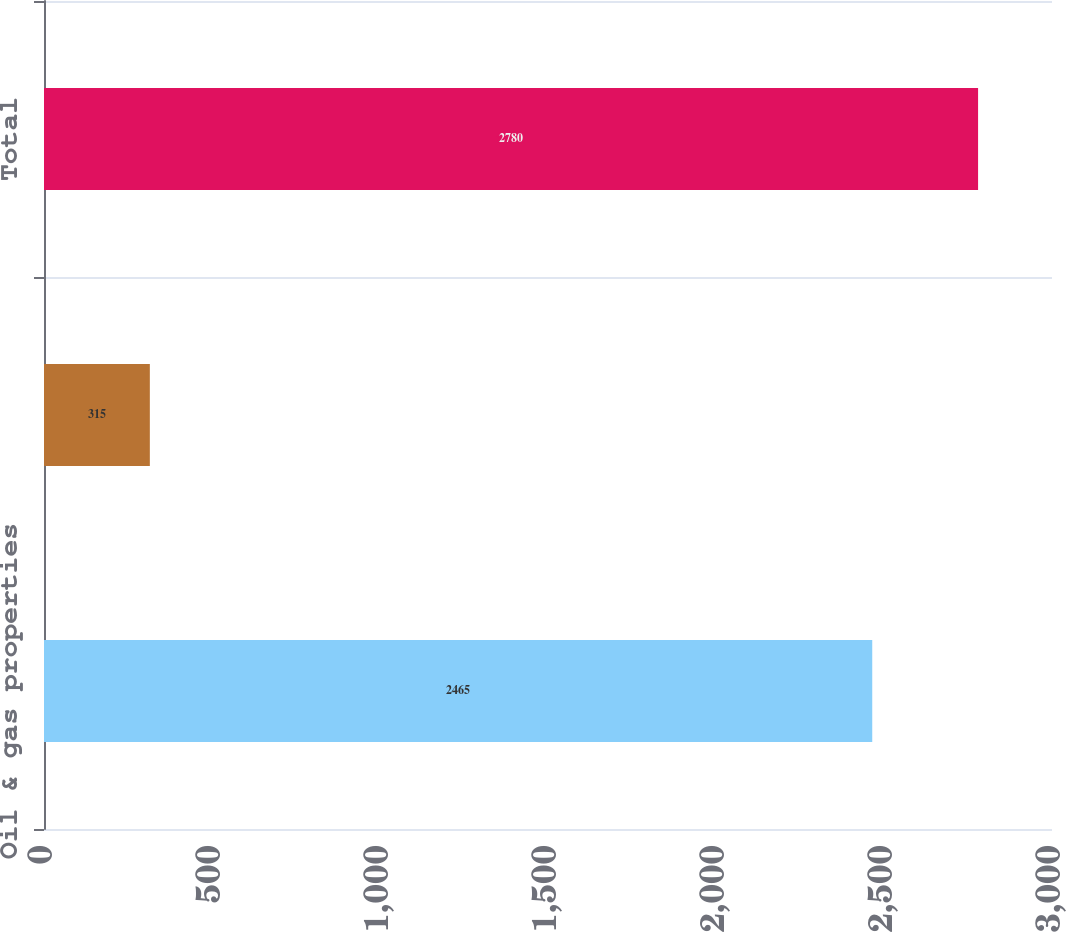Convert chart to OTSL. <chart><loc_0><loc_0><loc_500><loc_500><bar_chart><fcel>Oil & gas properties<fcel>Other properties<fcel>Total<nl><fcel>2465<fcel>315<fcel>2780<nl></chart> 